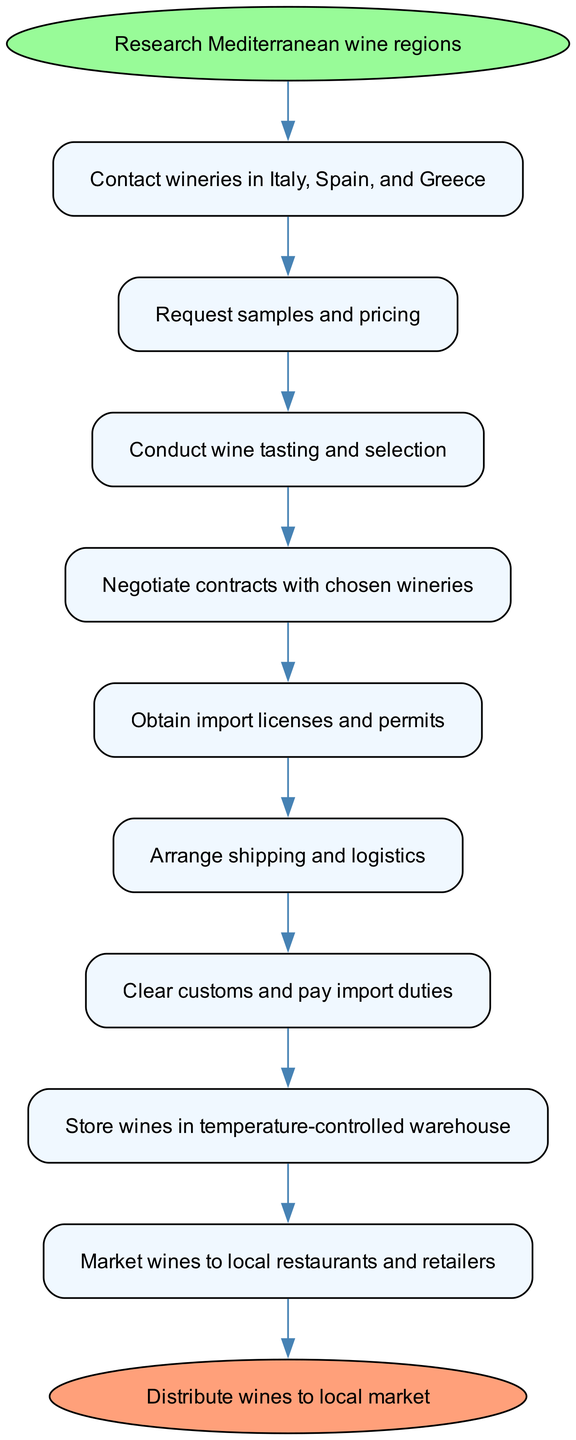What is the first step in the wine import process? The first step is "Research Mediterranean wine regions," as indicated by the start node in the diagram, which leads to the next step.
Answer: Research Mediterranean wine regions How many steps are there in total? By counting the nodes from the start to the end, there are a total of 10 steps in the process.
Answer: 10 What is the last step before distributing wines? The last step before distribution is "Market wines to local restaurants and retailers," as it is directly connected to the distribution node.
Answer: Market wines to local restaurants and retailers Which step involves legal compliance? The step "Obtain import licenses and permits" addresses legal compliance by ensuring that all necessary documentation is secured prior to importation.
Answer: Obtain import licenses and permits What is the relationship between selecting wines and negotiating contracts? The relationship is sequential; after conducting wine tasting and selection, the next logical step is to negotiate contracts with the chosen wineries. This flow indicates a dependent process where selection influences negotiation.
Answer: Sequential relationship 